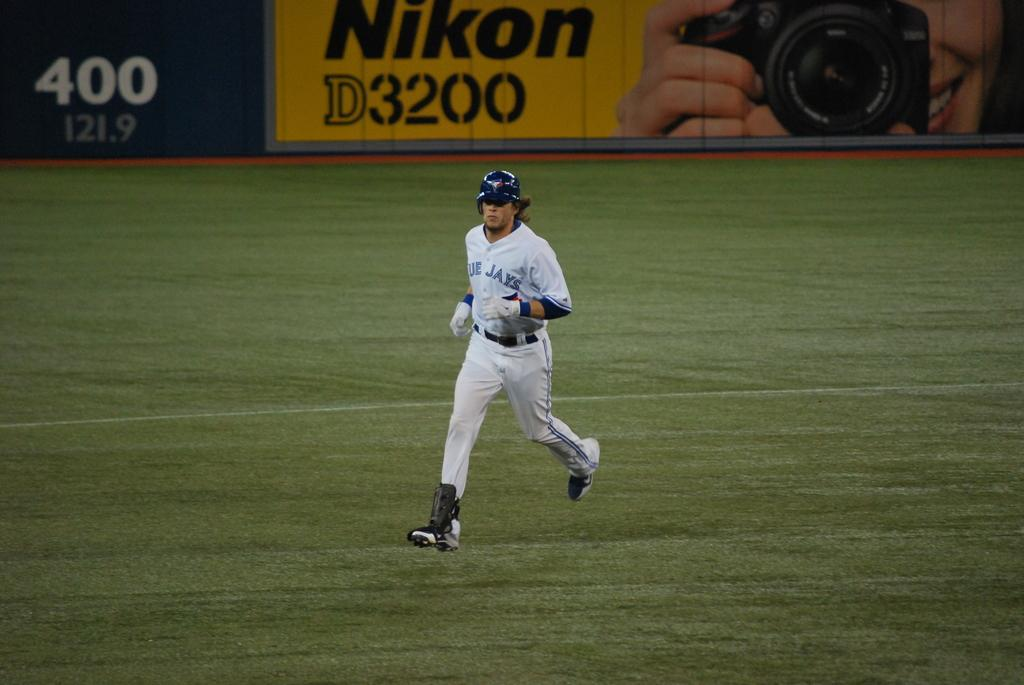<image>
Render a clear and concise summary of the photo. a baseball player in a Blue Jays jersey runs on a field 